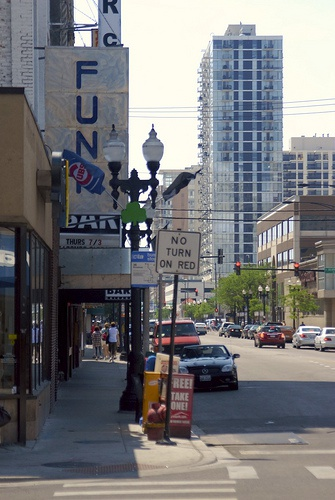Describe the objects in this image and their specific colors. I can see car in gray, black, navy, and darkblue tones, car in gray, black, navy, and brown tones, car in gray, black, maroon, and darkgray tones, car in gray, darkgray, and white tones, and car in gray, white, and black tones in this image. 